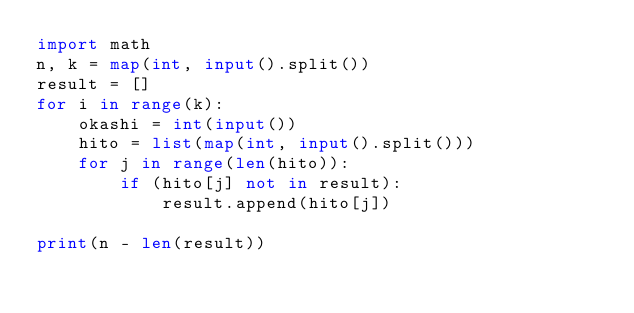<code> <loc_0><loc_0><loc_500><loc_500><_Python_>import math
n, k = map(int, input().split())
result = []
for i in range(k):
    okashi = int(input())
    hito = list(map(int, input().split()))
    for j in range(len(hito)):
        if (hito[j] not in result):
            result.append(hito[j])

print(n - len(result))</code> 